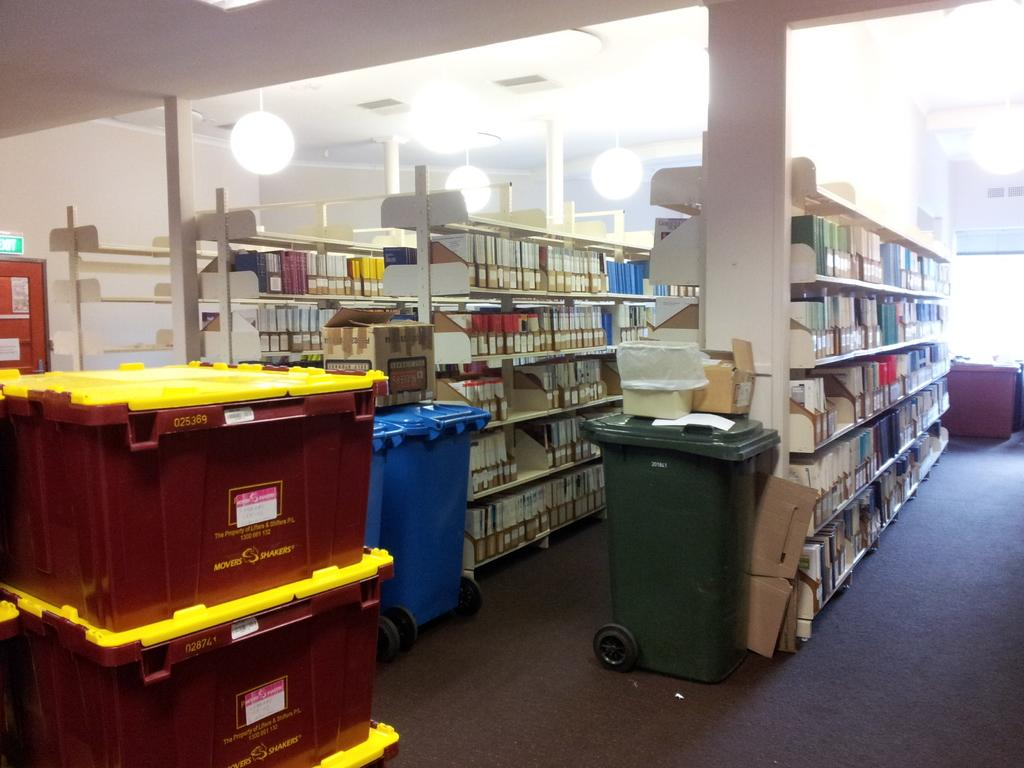<image>
Provide a brief description of the given image. A library that has boxes stacked that says Movers Shakers 